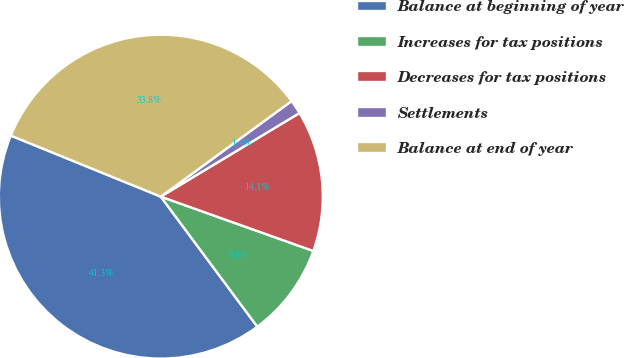<chart> <loc_0><loc_0><loc_500><loc_500><pie_chart><fcel>Balance at beginning of year<fcel>Increases for tax positions<fcel>Decreases for tax positions<fcel>Settlements<fcel>Balance at end of year<nl><fcel>41.31%<fcel>9.39%<fcel>14.08%<fcel>1.41%<fcel>33.8%<nl></chart> 